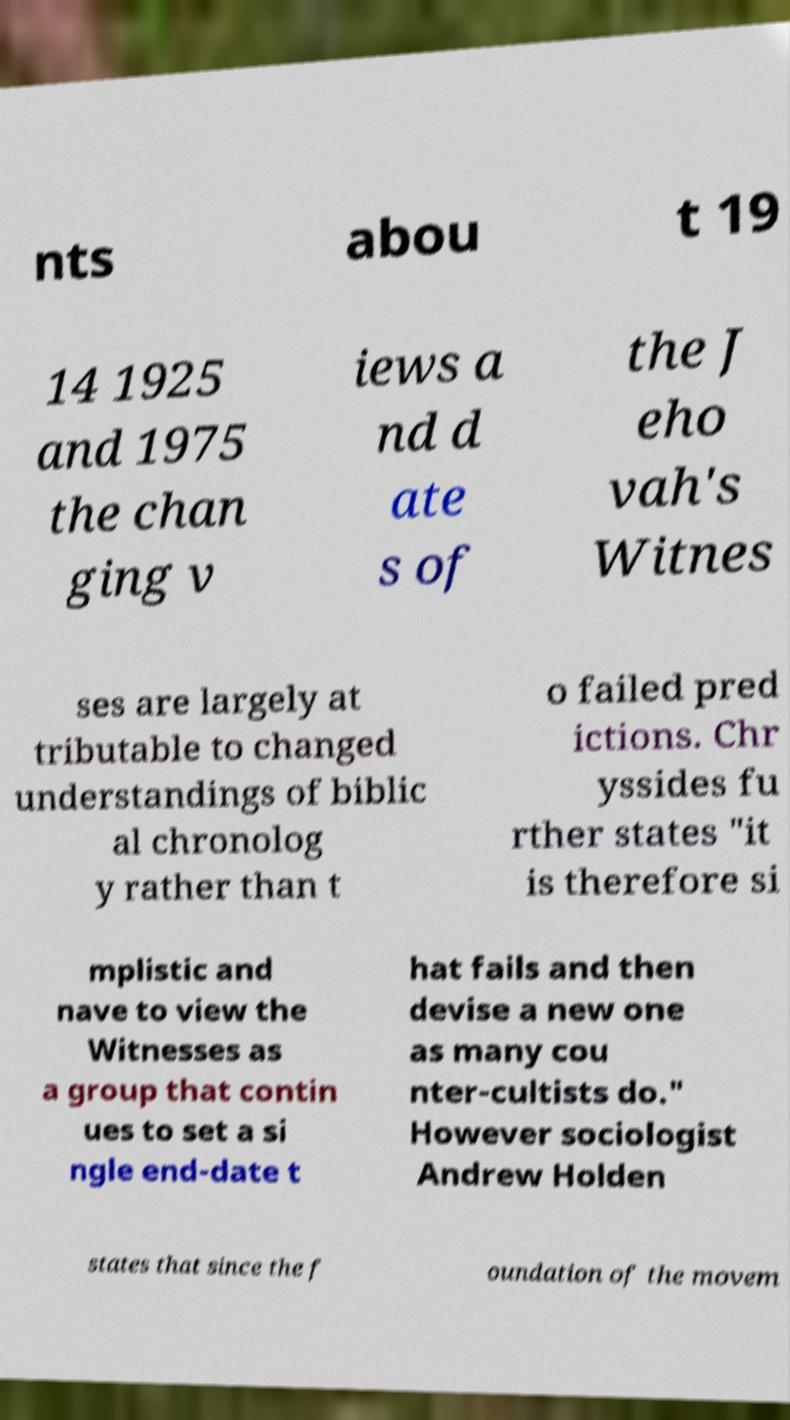Could you assist in decoding the text presented in this image and type it out clearly? nts abou t 19 14 1925 and 1975 the chan ging v iews a nd d ate s of the J eho vah's Witnes ses are largely at tributable to changed understandings of biblic al chronolog y rather than t o failed pred ictions. Chr yssides fu rther states "it is therefore si mplistic and nave to view the Witnesses as a group that contin ues to set a si ngle end-date t hat fails and then devise a new one as many cou nter-cultists do." However sociologist Andrew Holden states that since the f oundation of the movem 